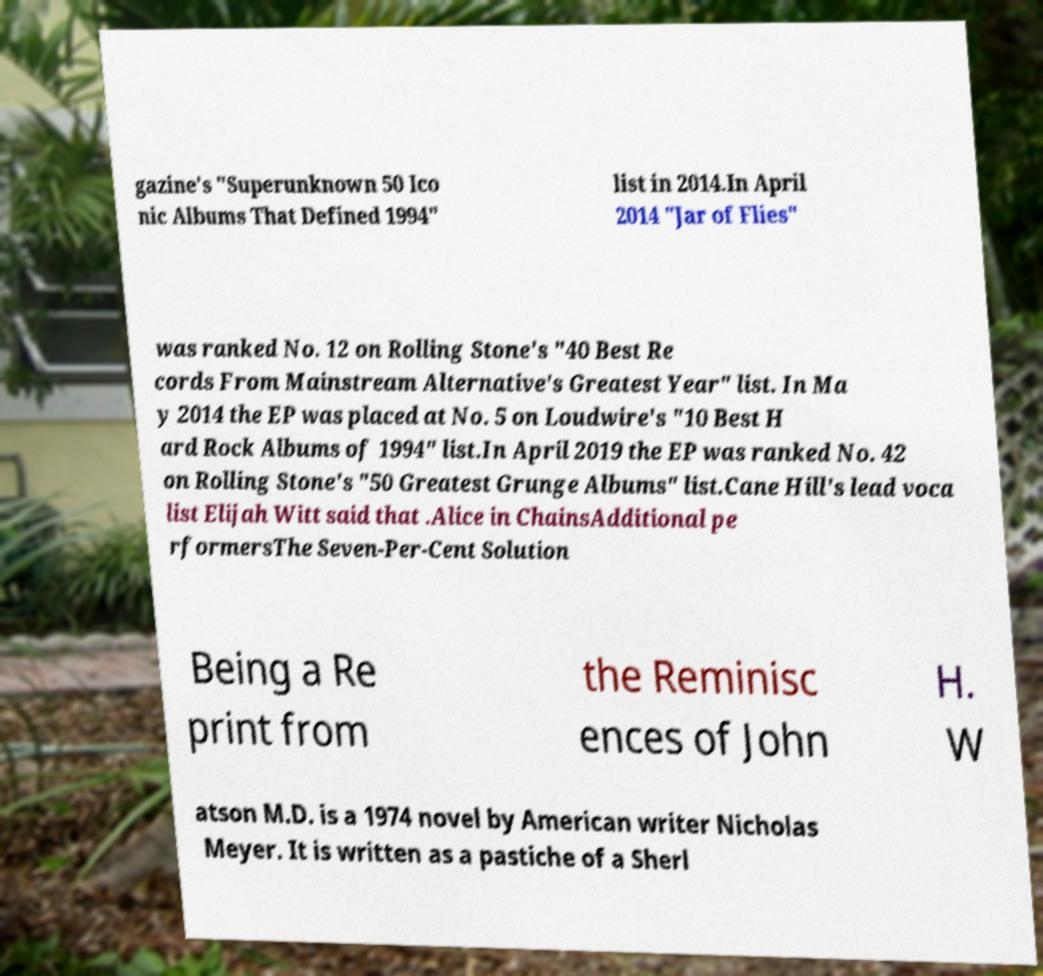There's text embedded in this image that I need extracted. Can you transcribe it verbatim? gazine's "Superunknown 50 Ico nic Albums That Defined 1994" list in 2014.In April 2014 "Jar of Flies" was ranked No. 12 on Rolling Stone's "40 Best Re cords From Mainstream Alternative's Greatest Year" list. In Ma y 2014 the EP was placed at No. 5 on Loudwire's "10 Best H ard Rock Albums of 1994" list.In April 2019 the EP was ranked No. 42 on Rolling Stone's "50 Greatest Grunge Albums" list.Cane Hill's lead voca list Elijah Witt said that .Alice in ChainsAdditional pe rformersThe Seven-Per-Cent Solution Being a Re print from the Reminisc ences of John H. W atson M.D. is a 1974 novel by American writer Nicholas Meyer. It is written as a pastiche of a Sherl 